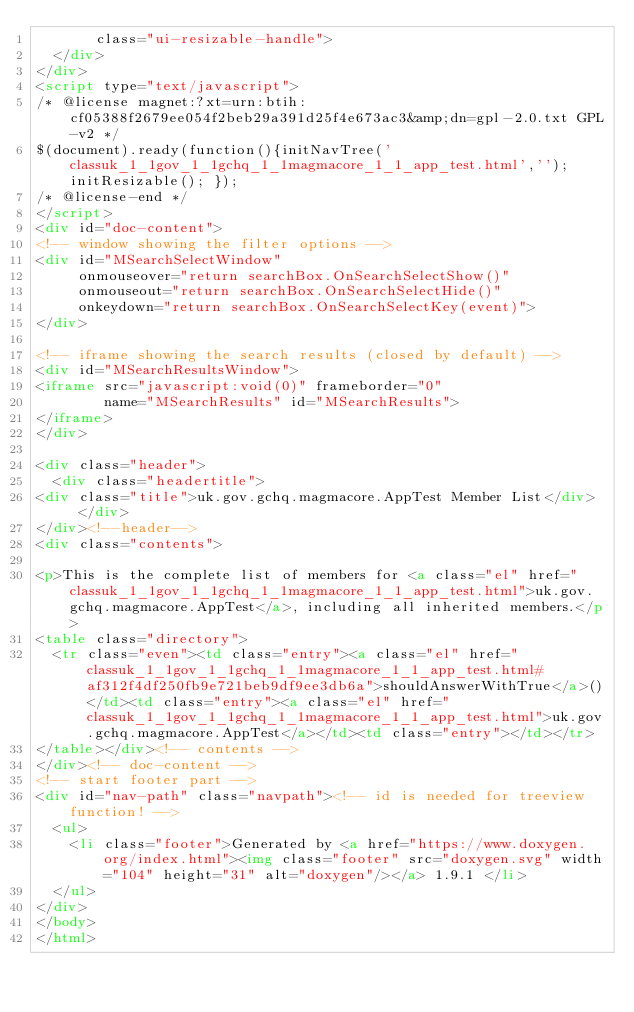Convert code to text. <code><loc_0><loc_0><loc_500><loc_500><_HTML_>       class="ui-resizable-handle">
  </div>
</div>
<script type="text/javascript">
/* @license magnet:?xt=urn:btih:cf05388f2679ee054f2beb29a391d25f4e673ac3&amp;dn=gpl-2.0.txt GPL-v2 */
$(document).ready(function(){initNavTree('classuk_1_1gov_1_1gchq_1_1magmacore_1_1_app_test.html',''); initResizable(); });
/* @license-end */
</script>
<div id="doc-content">
<!-- window showing the filter options -->
<div id="MSearchSelectWindow"
     onmouseover="return searchBox.OnSearchSelectShow()"
     onmouseout="return searchBox.OnSearchSelectHide()"
     onkeydown="return searchBox.OnSearchSelectKey(event)">
</div>

<!-- iframe showing the search results (closed by default) -->
<div id="MSearchResultsWindow">
<iframe src="javascript:void(0)" frameborder="0" 
        name="MSearchResults" id="MSearchResults">
</iframe>
</div>

<div class="header">
  <div class="headertitle">
<div class="title">uk.gov.gchq.magmacore.AppTest Member List</div>  </div>
</div><!--header-->
<div class="contents">

<p>This is the complete list of members for <a class="el" href="classuk_1_1gov_1_1gchq_1_1magmacore_1_1_app_test.html">uk.gov.gchq.magmacore.AppTest</a>, including all inherited members.</p>
<table class="directory">
  <tr class="even"><td class="entry"><a class="el" href="classuk_1_1gov_1_1gchq_1_1magmacore_1_1_app_test.html#af312f4df250fb9e721beb9df9ee3db6a">shouldAnswerWithTrue</a>()</td><td class="entry"><a class="el" href="classuk_1_1gov_1_1gchq_1_1magmacore_1_1_app_test.html">uk.gov.gchq.magmacore.AppTest</a></td><td class="entry"></td></tr>
</table></div><!-- contents -->
</div><!-- doc-content -->
<!-- start footer part -->
<div id="nav-path" class="navpath"><!-- id is needed for treeview function! -->
  <ul>
    <li class="footer">Generated by <a href="https://www.doxygen.org/index.html"><img class="footer" src="doxygen.svg" width="104" height="31" alt="doxygen"/></a> 1.9.1 </li>
  </ul>
</div>
</body>
</html>
</code> 